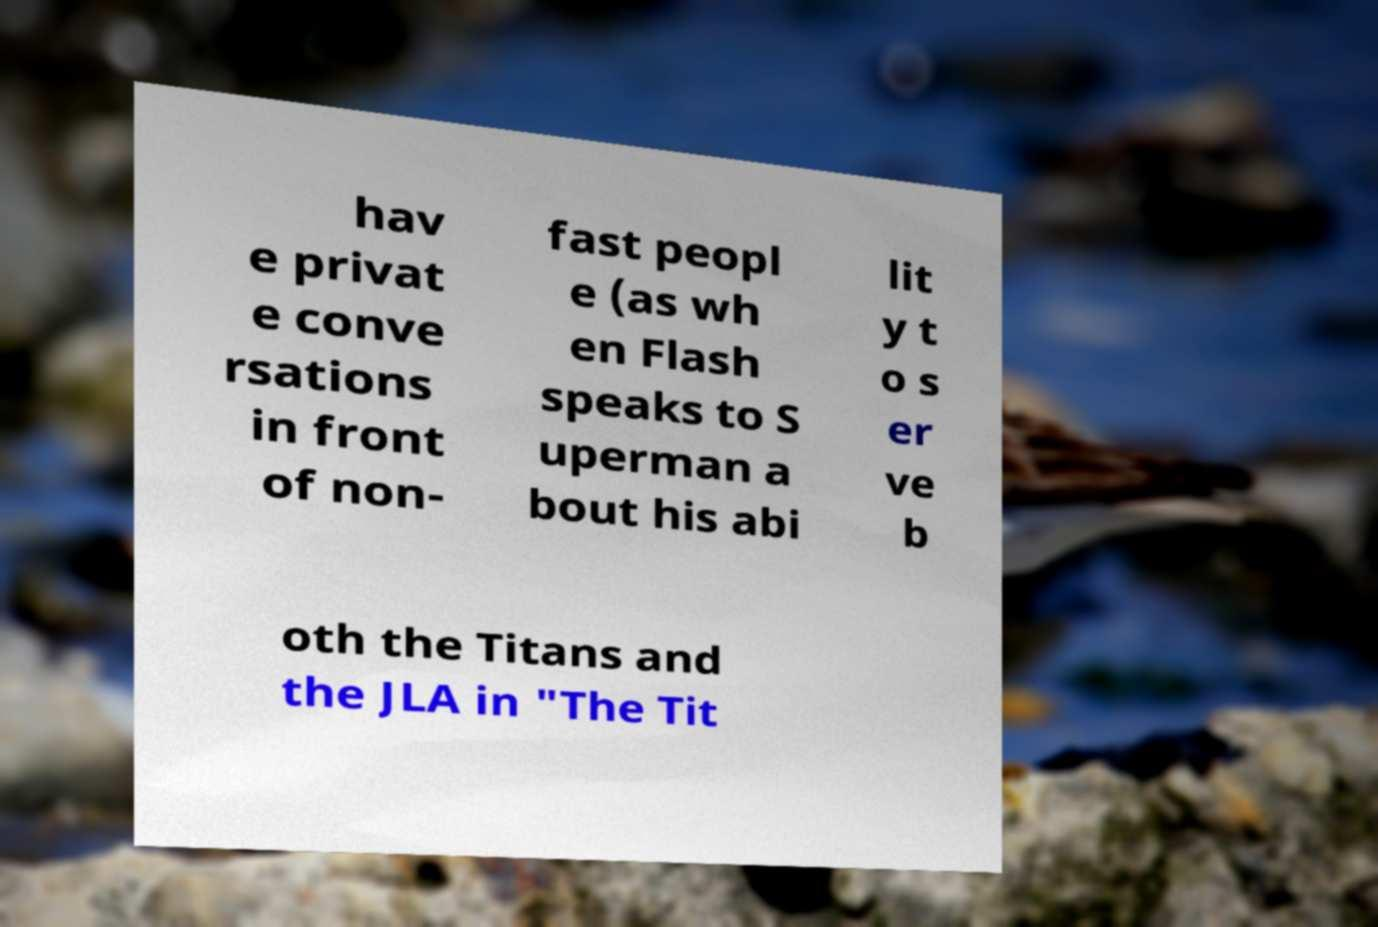Could you assist in decoding the text presented in this image and type it out clearly? hav e privat e conve rsations in front of non- fast peopl e (as wh en Flash speaks to S uperman a bout his abi lit y t o s er ve b oth the Titans and the JLA in "The Tit 